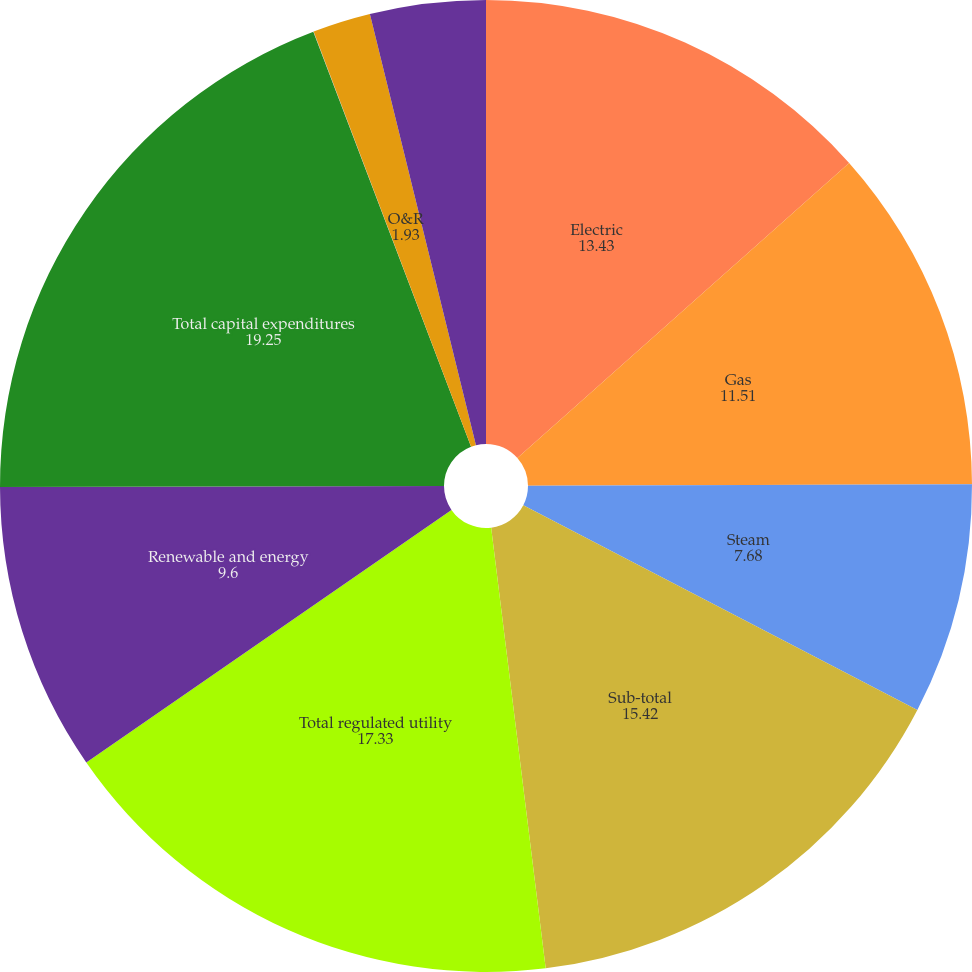Convert chart. <chart><loc_0><loc_0><loc_500><loc_500><pie_chart><fcel>Electric<fcel>Gas<fcel>Steam<fcel>Sub-total<fcel>Total regulated utility<fcel>Renewable and energy<fcel>Total capital expenditures<fcel>Con Edison - parent company<fcel>O&R<fcel>Competitive energy businesses<nl><fcel>13.43%<fcel>11.51%<fcel>7.68%<fcel>15.42%<fcel>17.33%<fcel>9.6%<fcel>19.25%<fcel>0.01%<fcel>1.93%<fcel>3.84%<nl></chart> 